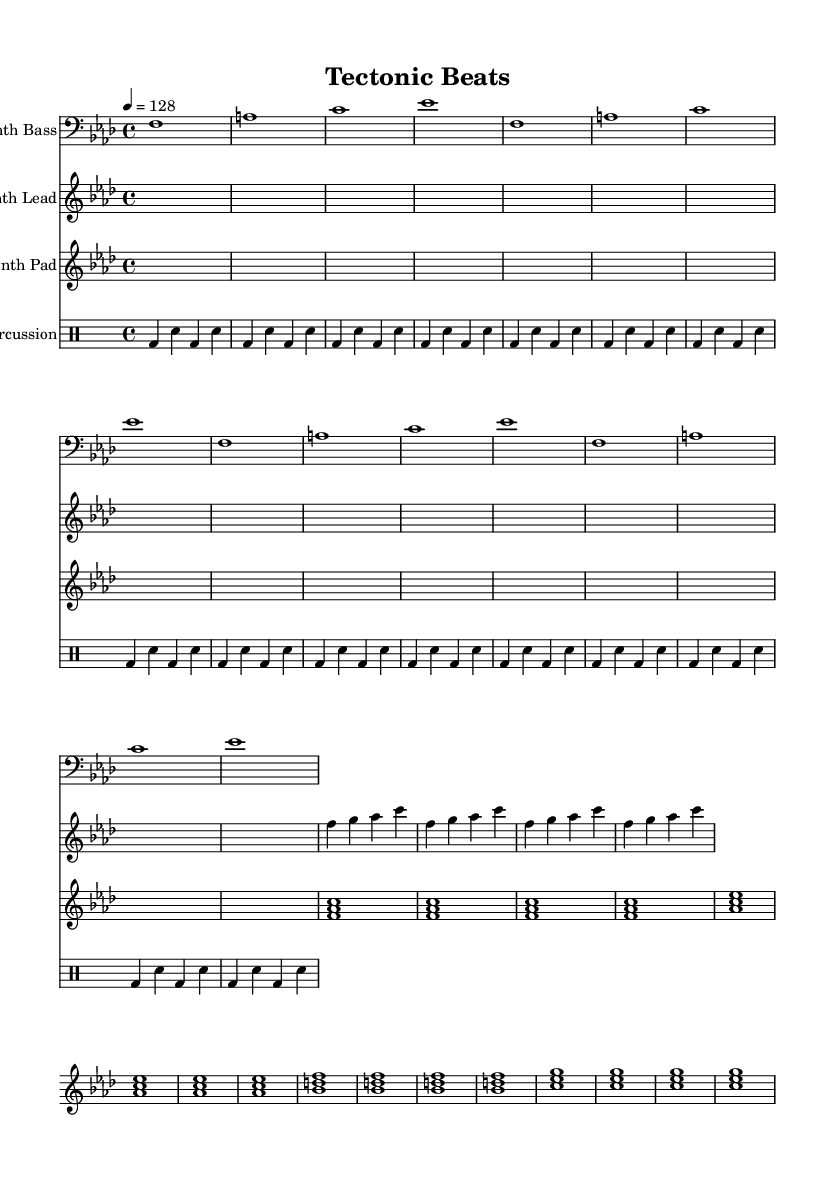What is the key signature of this music? The key signature is denoted at the beginning of the score. In this case, there is a flat sign on the B line, indicating B♭, and the other notes present do not add additional sharps or flats. Therefore, the key signature is one flat, which corresponds to F minor.
Answer: F minor What is the time signature of this music? The time signature is indicated at the beginning of the score after the key signature. Here, it is shown as "4/4", which means there are four beats in each measure and the quarter note gets one beat.
Answer: 4/4 What is the tempo marking for this piece? The tempo indication is found in the score after the time signature. It states "4 = 128", which means that there are 128 beats per minute with the quarter note receiving a beat.
Answer: 128 How many measures are in the synth lead section? To determine the number of measures in the synth lead section, we can count the measures written for the synth lead staff from the score. Each line of music usually represents one measure. There are four measures visible.
Answer: 4 What type of music is this composition? The title "Tectonic Beats" suggests a genre that reflects the themes of geology and the associated volcanic activities, aligning with the principles of house music, particularly progressive house, known for its electronic sounds and emotional depth.
Answer: Progressive house What rhythm pattern is used in the percussion part? To analyze the rhythm in the percussion part, we observe the drum notation, which consists of repeated patterns. Here, the use of kick drum (bd) and snare (sn) is noted, illustrating a basic four-beat pattern that repeats across the measures.
Answer: Kick and snare pattern, repeated Which instrument plays the bass part? The instrument designated for the bass part is specified at the start of the staff for the synth bass, which is indicated as "Synth Bass," showing it is exclusively focused on lower frequency sounds typical of bass lines in music compositions.
Answer: Synth Bass 